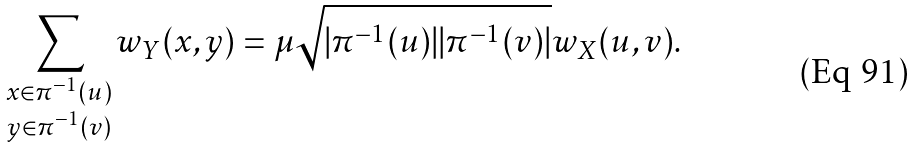<formula> <loc_0><loc_0><loc_500><loc_500>\sum _ { \substack { x \in \pi ^ { - 1 } ( u ) \\ y \in \pi ^ { - 1 } ( v ) } } w _ { Y } ( x , y ) = \mu \sqrt { | \pi ^ { - 1 } ( u ) | | \pi ^ { - 1 } ( v ) | } w _ { X } ( u , v ) .</formula> 